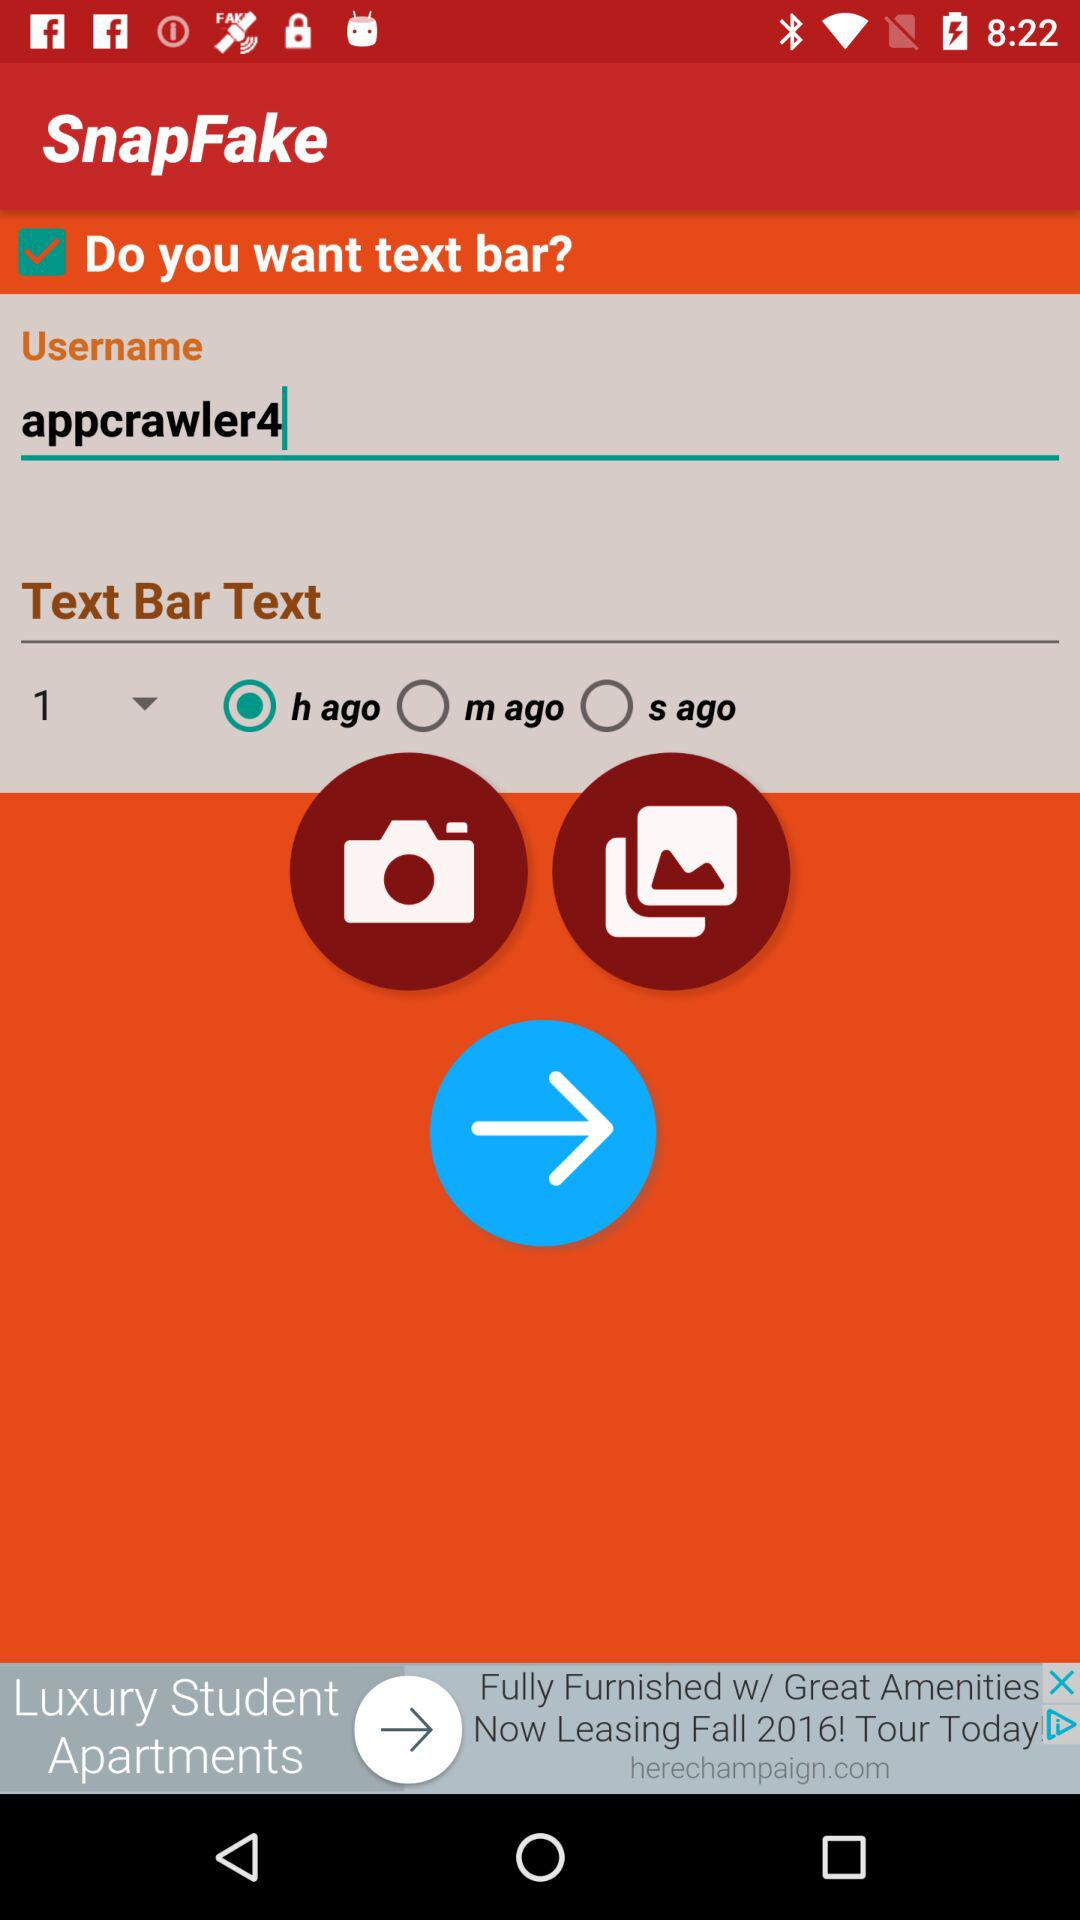What is the username? The username is "appcrawler4". 